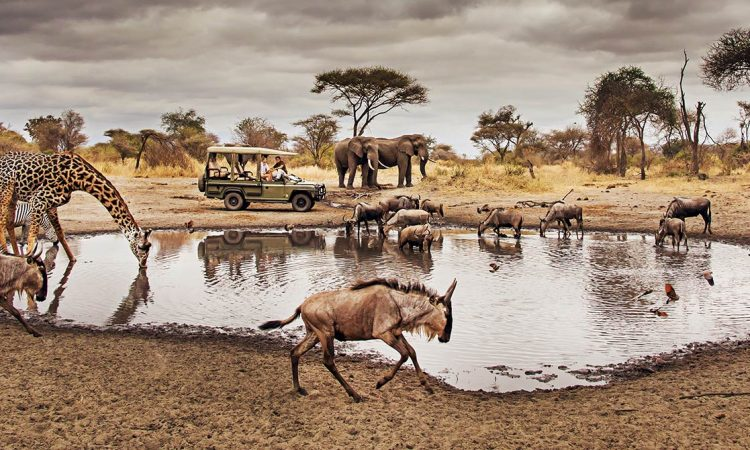What does the presence of safari tourists suggest about this environment? Tourists visiting this area on a safari excursion indicate that this region is protected and established for wildlife conservation and viewing. The presence of safari vehicles suggests that ecotourism is a significant activity here, likely contributing to the local economy and conservation efforts. Moreover, it reflects the delicate balance between allowing people to witness these magnificent animals in their natural habitat while striving to minimize human impact on the environment. How do safari parks like the one likely depicted manage to maintain this balance? Safari parks manage this balance by implementing strict regulations on tour activities, vehicle routes, and visitor behavior to ensure minimal disturbance to wildlife. Guides are often trained to educate tourists about responsible observation practices, and park authorities routinely monitor the health of both the animals and their habitats. The money generated from tourism can also go back into funding conservation initiatives, anti-poaching efforts, and community development projects, thereby fostering a sustainable model that benefits both the wildlife and the local human population. 